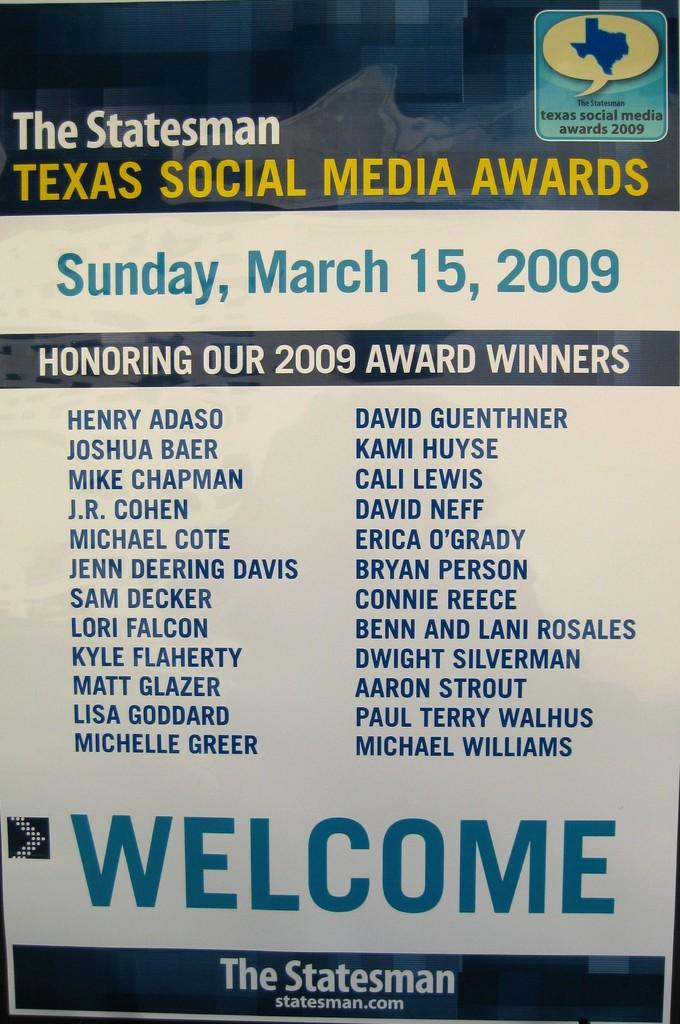<image>
Offer a succinct explanation of the picture presented. Texas will have social media awards on sunday. 